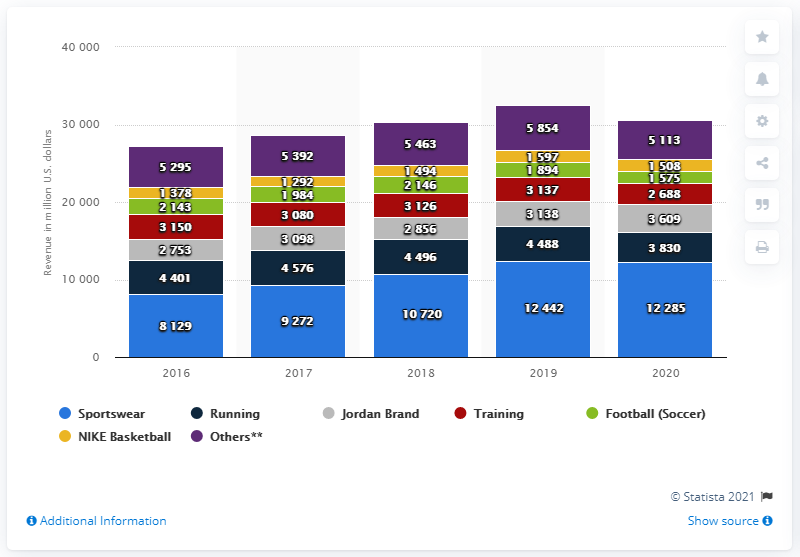List a handful of essential elements in this visual. In 2020, the sportswear category of Nike generated approximately $122,850,000 in revenue in the United States. 